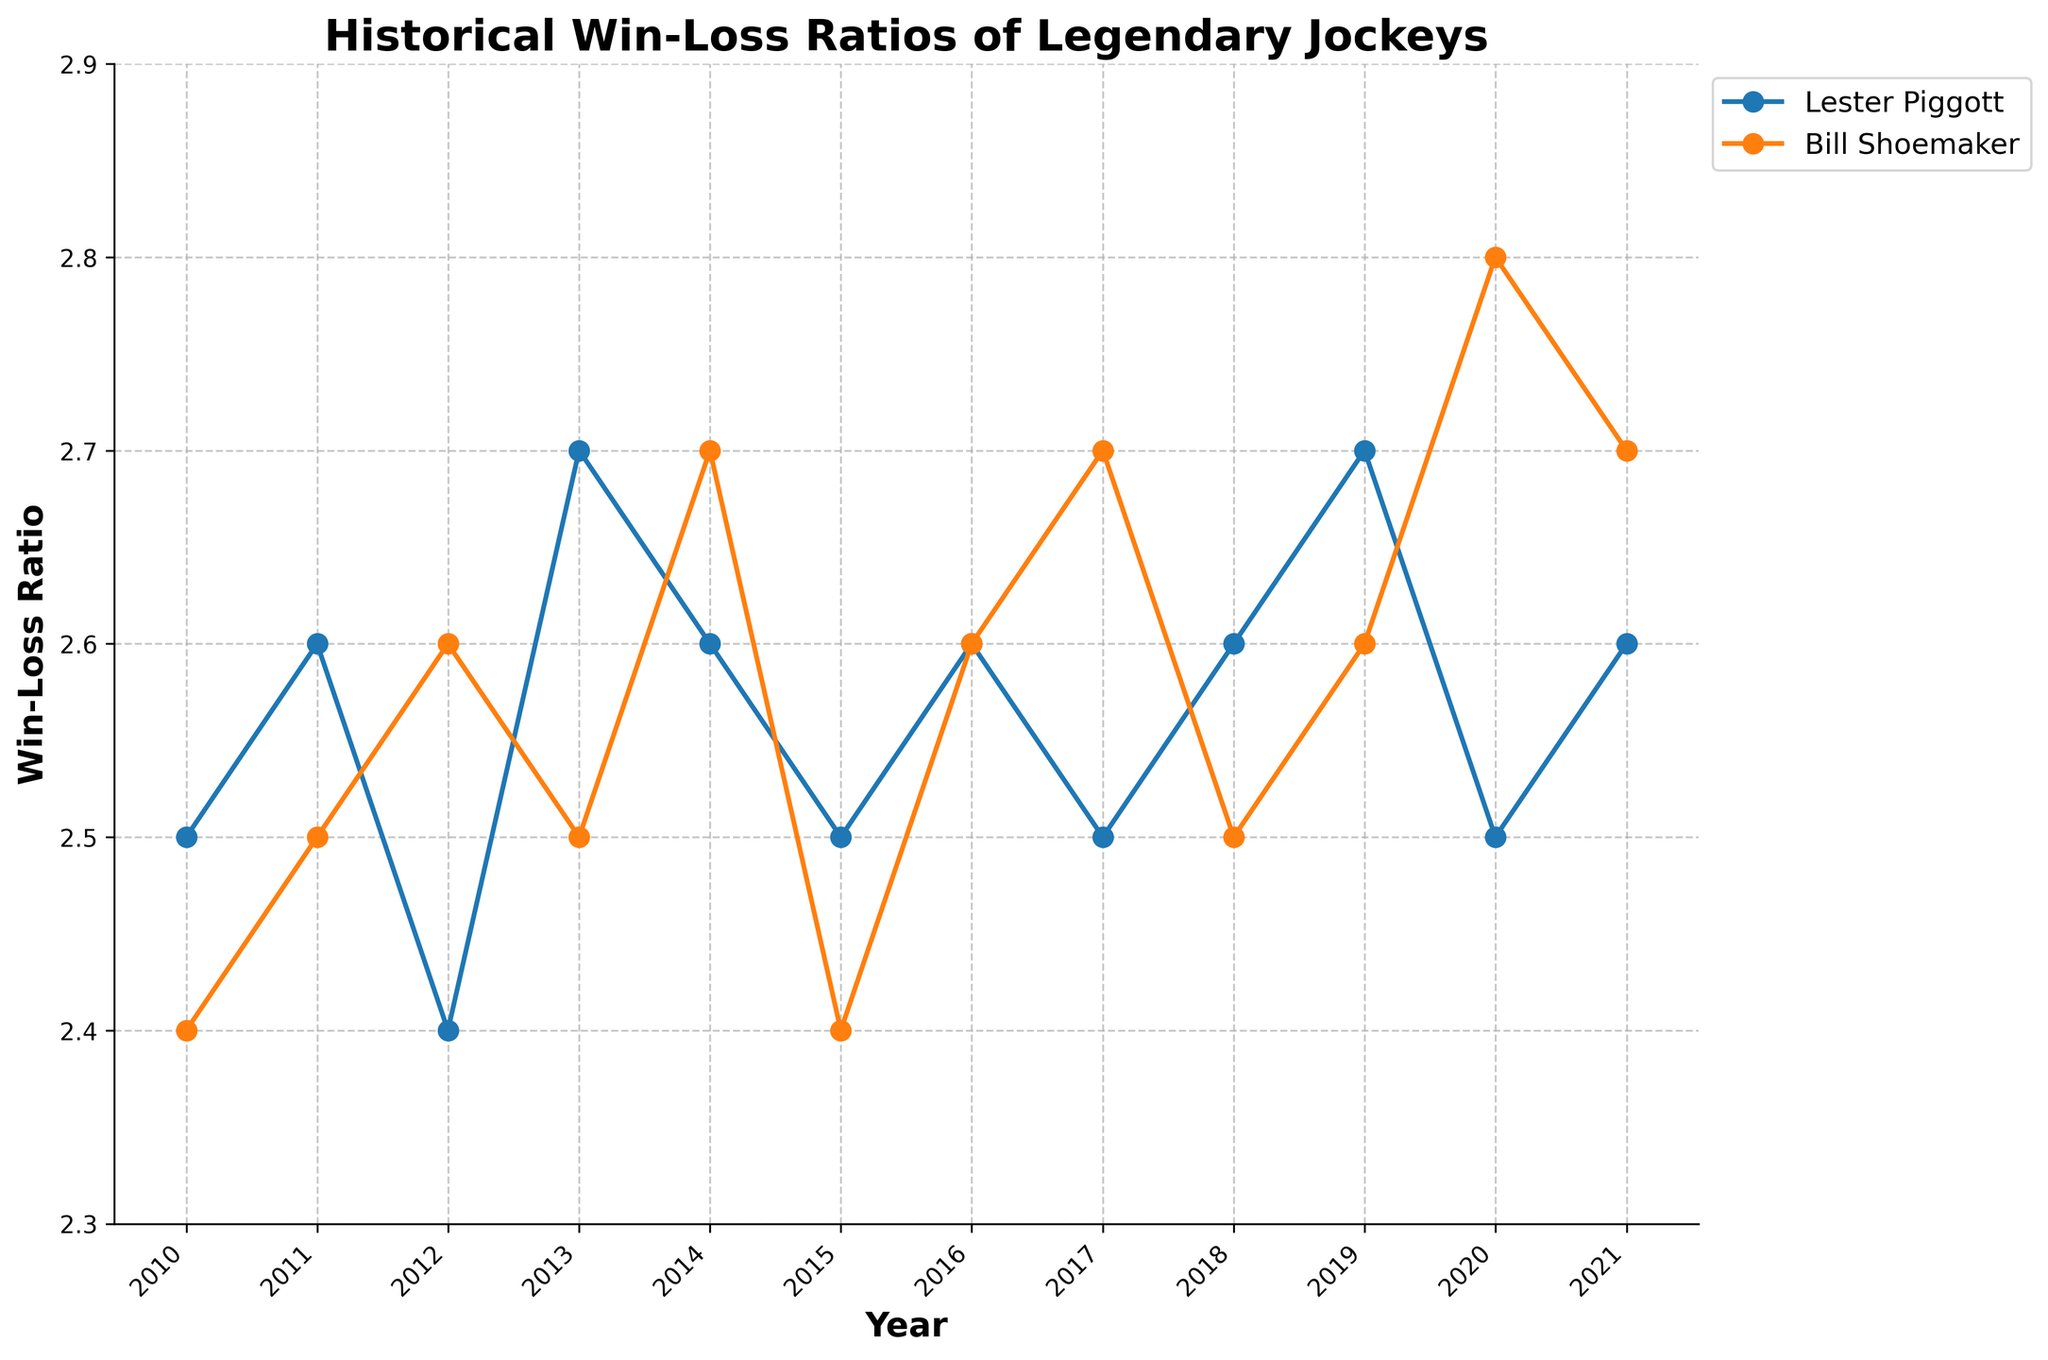What's the title of the plot? The title is usually located at the top center of the plot and provides a summary of what the plot represents.
Answer: Historical Win-Loss Ratios of Legendary Jockeys When did Lester Piggott have his highest Win-Loss Ratio? By examining the plot, we can see the peak point in Lester Piggott's line. Locate the x-axis year corresponding to the maximum y-axis value.
Answer: 2019 Which jockey had a higher Win-Loss Ratio in 2020? Look for the data points on the plot for both jockeys in the year 2020. Compare their y-axis values to determine which one is higher.
Answer: Bill Shoemaker What is the overall trend for Bill Shoemaker's Win-Loss Ratio from 2010 to 2021? Observe the trajectory of Bill Shoemaker's line from the beginning to the end of the plot. Notice if the line overall rises, falls, or remains relatively constant.
Answer: Increasing During which year did both jockeys have equal Win-Loss Ratios and what was the value? Look for the intersection point of the two lines on the plot. Identify the year (x-axis) and the Win-Loss Ratio (y-axis) at the intersection.
Answer: 2016, 2.6 How many times did Lester Piggott's Win-Loss Ratio fall below 2.6? Locate each point on Lester Piggott's line. Count the number of points that are below the y-axis value of 2.6.
Answer: 5 What is the difference in Win-Loss Ratios between the jockeys in 2015? Identify the y-axis values for both jockeys in 2015. Subtract the value of Bill Shoemaker from Lester Piggott's value.
Answer: 0.1 Did either jockey experience a consistent rise or fall in their Win-Loss Ratio throughout the entire period? Observe the overall trend of each jockey's line over the whole period. A consistent rise or fall would mean it's steadily increasing or decreasing.
Answer: No, both have fluctuations Which jockey shows more variability in their Win-Loss Ratio over the years? Analyze the fluctuation in the lines for both jockeys. Greater variability will show larger ups and downs in the line.
Answer: Bill Shoemaker In which year did Bill Shoemaker reach his peak Win-Loss Ratio, and what was the value? Locate the highest point on Bill Shoemaker's line and note the corresponding year and y-axis value.
Answer: 2020, 2.8 